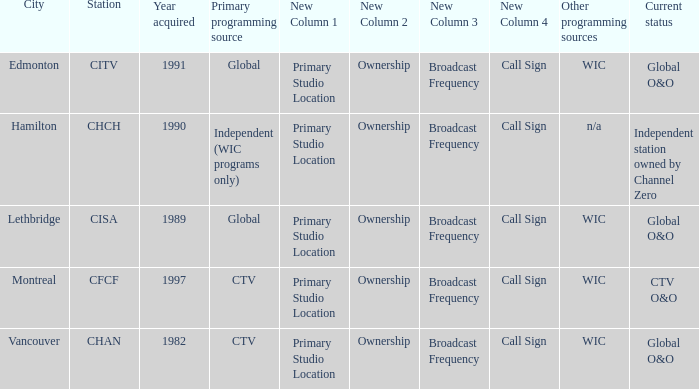Could you parse the entire table as a dict? {'header': ['City', 'Station', 'Year acquired', 'Primary programming source', 'New Column 1', 'New Column 2', 'New Column 3', 'New Column 4', 'Other programming sources', 'Current status'], 'rows': [['Edmonton', 'CITV', '1991', 'Global', 'Primary Studio Location', 'Ownership', 'Broadcast Frequency', 'Call Sign', 'WIC', 'Global O&O'], ['Hamilton', 'CHCH', '1990', 'Independent (WIC programs only)', 'Primary Studio Location', 'Ownership', 'Broadcast Frequency', 'Call Sign', 'n/a', 'Independent station owned by Channel Zero'], ['Lethbridge', 'CISA', '1989', 'Global', 'Primary Studio Location', 'Ownership', 'Broadcast Frequency', 'Call Sign', 'WIC', 'Global O&O'], ['Montreal', 'CFCF', '1997', 'CTV', 'Primary Studio Location', 'Ownership', 'Broadcast Frequency', 'Call Sign', 'WIC', 'CTV O&O'], ['Vancouver', 'CHAN', '1982', 'CTV', 'Primary Studio Location', 'Ownership', 'Broadcast Frequency', 'Call Sign', 'WIC', 'Global O&O']]} How many is the minimum for citv 1991.0. 